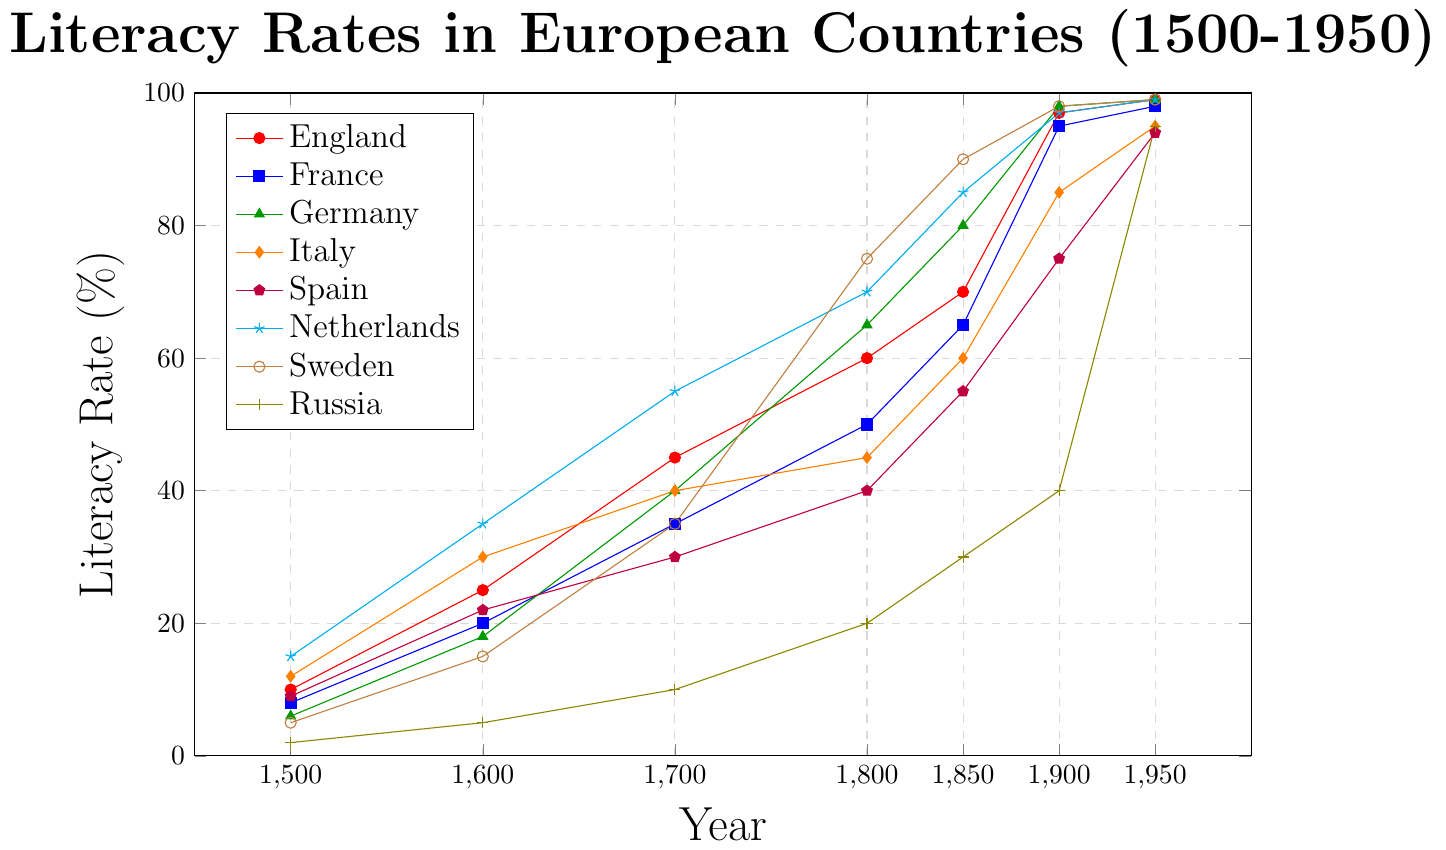Which country had the highest literacy rate in 1500? From the figure, the Netherlands had the highest literacy rate in 1500 with a rate of 15%.
Answer: Netherlands Which country showed the most significant increase in literacy rate between 1800 and 1850? By inspecting the figure, Sweden's literacy rate increased from 35% in 1800 to 90% in 1850, a rise of 55%.
Answer: Sweden In what year did Germany surpass France in literacy rate? Germany surpassed France in literacy rate around 1800, where Germany had 65% and France had 50%.
Answer: 1800 How did the literacy rate in Russia in 1900 compare to the literacy rate of Spain in 1700? Russia's literacy rate in 1900 was about 40%, while Spain's literacy rate in 1700 was 30%. Hence, Russia in 1900 had a higher literacy rate than Spain in 1700 by 10%.
Answer: Russia in 1900 was higher Which country achieved near-universal literacy rates (95% and above) first, and in which year? According to the figure, England achieved approximately 97% literacy rate around 1900, reaching near-universal literacy first.
Answer: England in 1900 Identify the two countries that had the same literacy rate in 1950. From the visual representation, both England and Sweden had a literacy rate of 99% in 1950.
Answer: England and Sweden Which country experienced a slower growth in literacy rate from 1600 to 1700 compared to others? By looking at the figure, Russia's literacy rate showed a moderate increase from 5% in 1600 to 10% in 1700, indicating slower growth compared to other countries.
Answer: Russia What is the total change in the literacy rate of Italy from 1600 to 1900? Italy's literacy rate increased from 30% in 1600 to 85% in 1900, showing a total change of 55%.
Answer: 55% In which period did the Netherlands experience the fastest growth in literacy rate? The Netherlands had the fastest increase in literacy rate from 1600 to 1700, growing from 35% to 55%, a 20% rise.
Answer: 1600 to 1700 Which country had the lowest literacy rate in 1800, and what was it? According to the plot, Russia had the lowest literacy rate in 1800, which was 20%.
Answer: Russia, 20% 